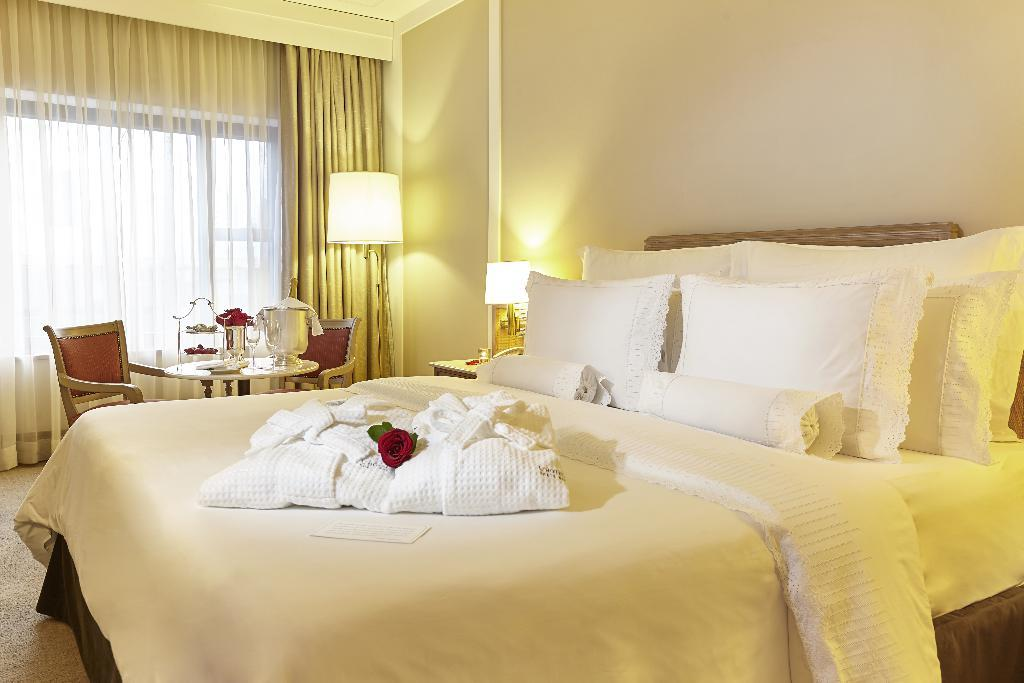What type of furniture is the main subject in the image? There is a bed in the image. What is covering the bed? There is a bed sheet on the bed. Are there any decorative elements in the image? Yes, there is a flower in the image. How many pillows are on the bed? There are pillows on the bed. What can be seen in the background of the image? There is a wall, a lamp, a table, chairs, a curtain, and a board in the background of the image. What is on the table in the background? There are objects on the table. How many units of need are required to complete the ghost's task in the image? There is no ghost or task present in the image, so it is not possible to determine the number of units of need required. 